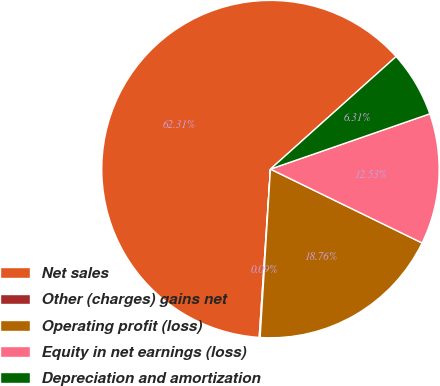Convert chart. <chart><loc_0><loc_0><loc_500><loc_500><pie_chart><fcel>Net sales<fcel>Other (charges) gains net<fcel>Operating profit (loss)<fcel>Equity in net earnings (loss)<fcel>Depreciation and amortization<nl><fcel>62.32%<fcel>0.09%<fcel>18.76%<fcel>12.53%<fcel>6.31%<nl></chart> 